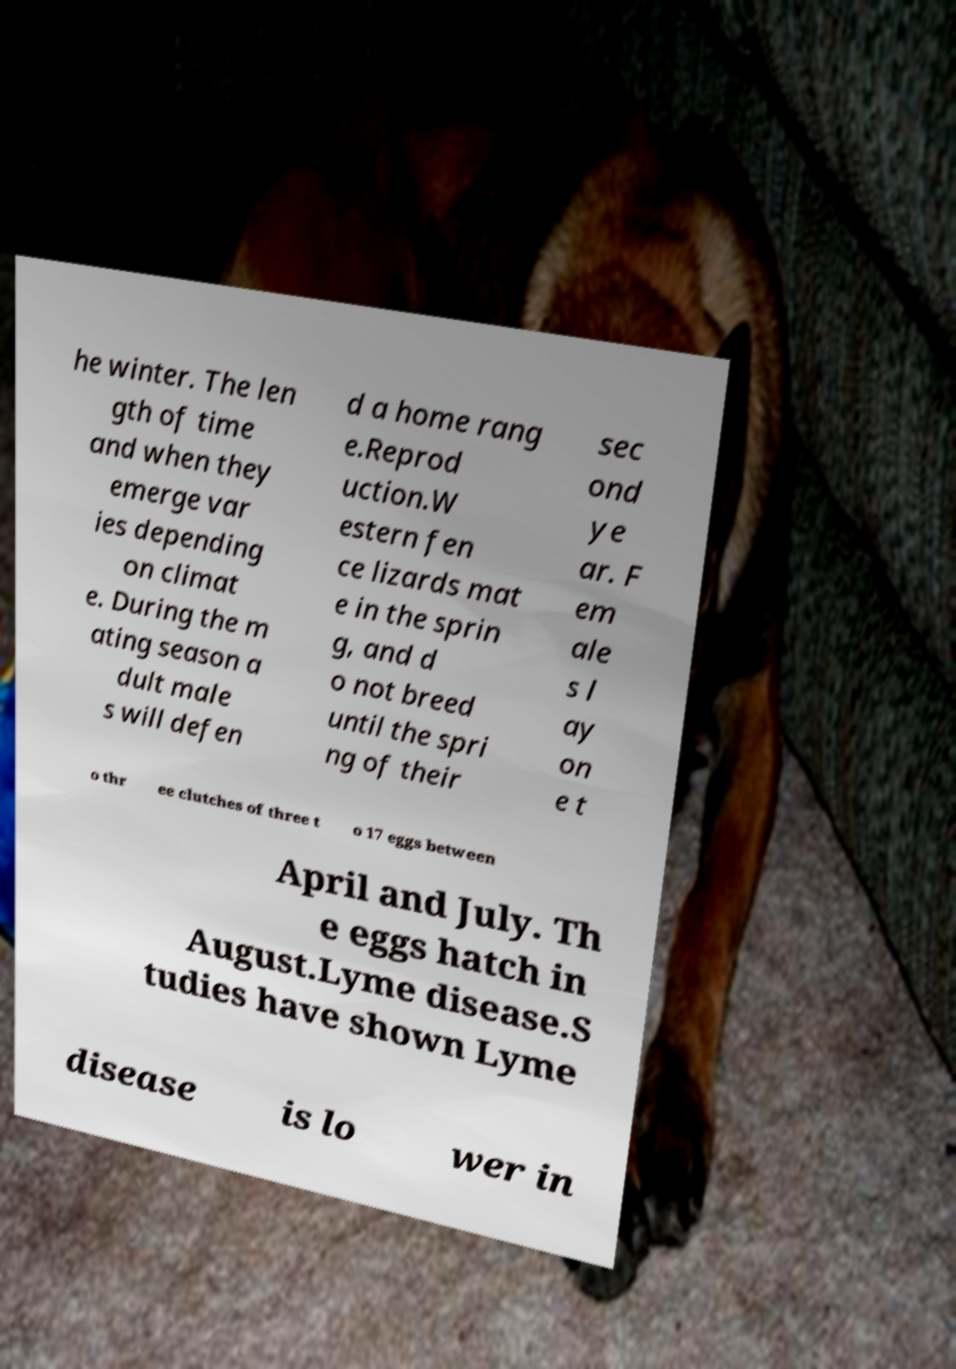Could you assist in decoding the text presented in this image and type it out clearly? he winter. The len gth of time and when they emerge var ies depending on climat e. During the m ating season a dult male s will defen d a home rang e.Reprod uction.W estern fen ce lizards mat e in the sprin g, and d o not breed until the spri ng of their sec ond ye ar. F em ale s l ay on e t o thr ee clutches of three t o 17 eggs between April and July. Th e eggs hatch in August.Lyme disease.S tudies have shown Lyme disease is lo wer in 